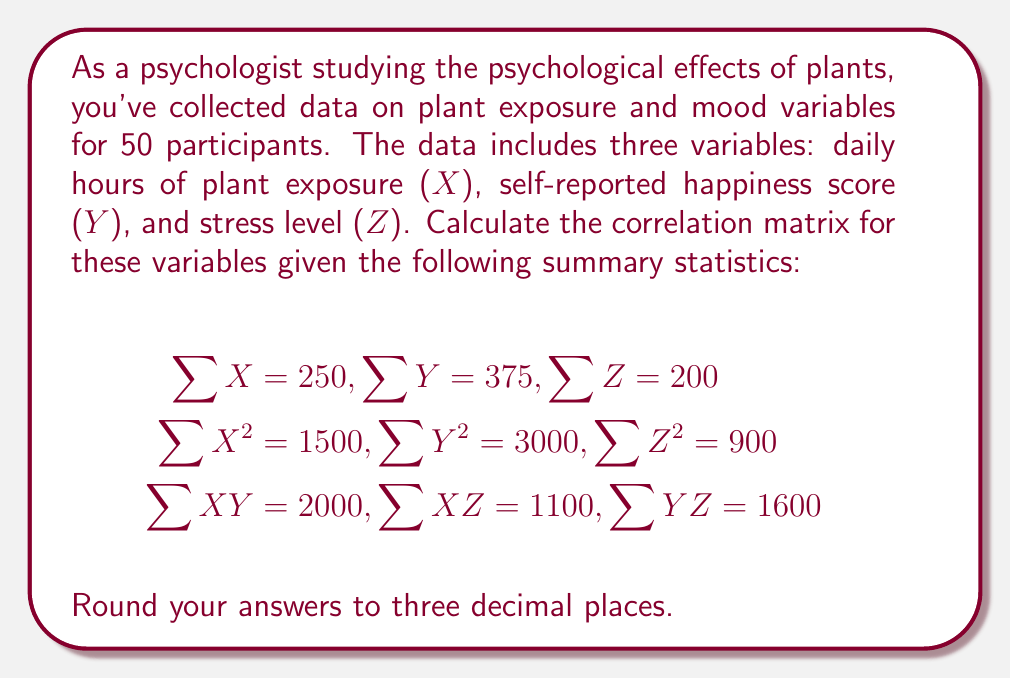Show me your answer to this math problem. To calculate the correlation matrix, we need to follow these steps:

1. Calculate the means of X, Y, and Z:
   $$\bar{X} = \frac{\sum X}{n} = \frac{250}{50} = 5$$
   $$\bar{Y} = \frac{\sum Y}{n} = \frac{375}{50} = 7.5$$
   $$\bar{Z} = \frac{\sum Z}{n} = \frac{200}{50} = 4$$

2. Calculate the variances of X, Y, and Z:
   $$s_X^2 = \frac{\sum X^2}{n} - \bar{X}^2 = \frac{1500}{50} - 5^2 = 5$$
   $$s_Y^2 = \frac{\sum Y^2}{n} - \bar{Y}^2 = \frac{3000}{50} - 7.5^2 = 3.75$$
   $$s_Z^2 = \frac{\sum Z^2}{n} - \bar{Z}^2 = \frac{900}{50} - 4^2 = 2$$

3. Calculate the standard deviations:
   $$s_X = \sqrt{5} \approx 2.236$$
   $$s_Y = \sqrt{3.75} \approx 1.936$$
   $$s_Z = \sqrt{2} \approx 1.414$$

4. Calculate the covariances:
   $$Cov(X,Y) = \frac{\sum XY}{n} - \bar{X}\bar{Y} = \frac{2000}{50} - 5(7.5) = 2.5$$
   $$Cov(X,Z) = \frac{\sum XZ}{n} - \bar{X}\bar{Z} = \frac{1100}{50} - 5(4) = 2$$
   $$Cov(Y,Z) = \frac{\sum YZ}{n} - \bar{Y}\bar{Z} = \frac{1600}{50} - 7.5(4) = 2$$

5. Calculate the correlations:
   $$r_{XY} = \frac{Cov(X,Y)}{s_X s_Y} = \frac{2.5}{2.236 \times 1.936} \approx 0.577$$
   $$r_{XZ} = \frac{Cov(X,Z)}{s_X s_Z} = \frac{2}{2.236 \times 1.414} \approx 0.632$$
   $$r_{YZ} = \frac{Cov(Y,Z)}{s_Y s_Z} = \frac{2}{1.936 \times 1.414} \approx 0.730$$

6. Construct the correlation matrix:
   $$\begin{bmatrix}
   1 & r_{XY} & r_{XZ} \\
   r_{XY} & 1 & r_{YZ} \\
   r_{XZ} & r_{YZ} & 1
   \end{bmatrix}$$
Answer: $$\begin{bmatrix}
1.000 & 0.577 & 0.632 \\
0.577 & 1.000 & 0.730 \\
0.632 & 0.730 & 1.000
\end{bmatrix}$$ 